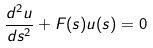Convert formula to latex. <formula><loc_0><loc_0><loc_500><loc_500>\frac { d ^ { 2 } u } { d s ^ { 2 } } + F ( s ) u ( s ) = 0</formula> 